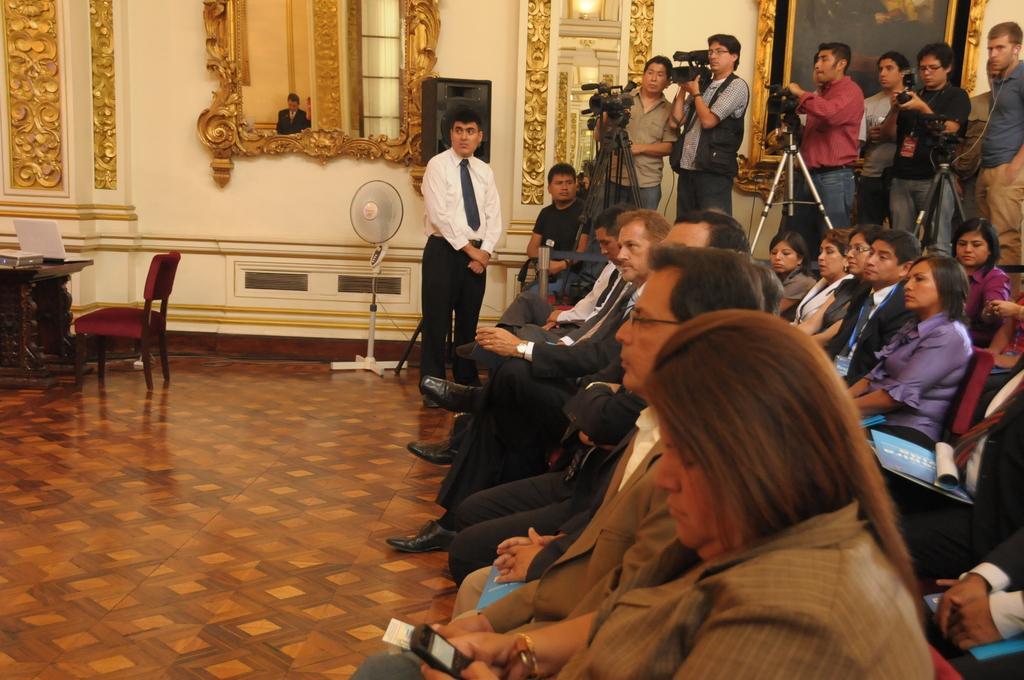How would you summarize this image in a sentence or two? In this image I can see people were few are standing and holding cameras and rest all are sitting on chairs. I can also see a fan, a mirror, a chair, a table and a laptop. 